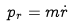<formula> <loc_0><loc_0><loc_500><loc_500>p _ { r } = m { \dot { r } }</formula> 